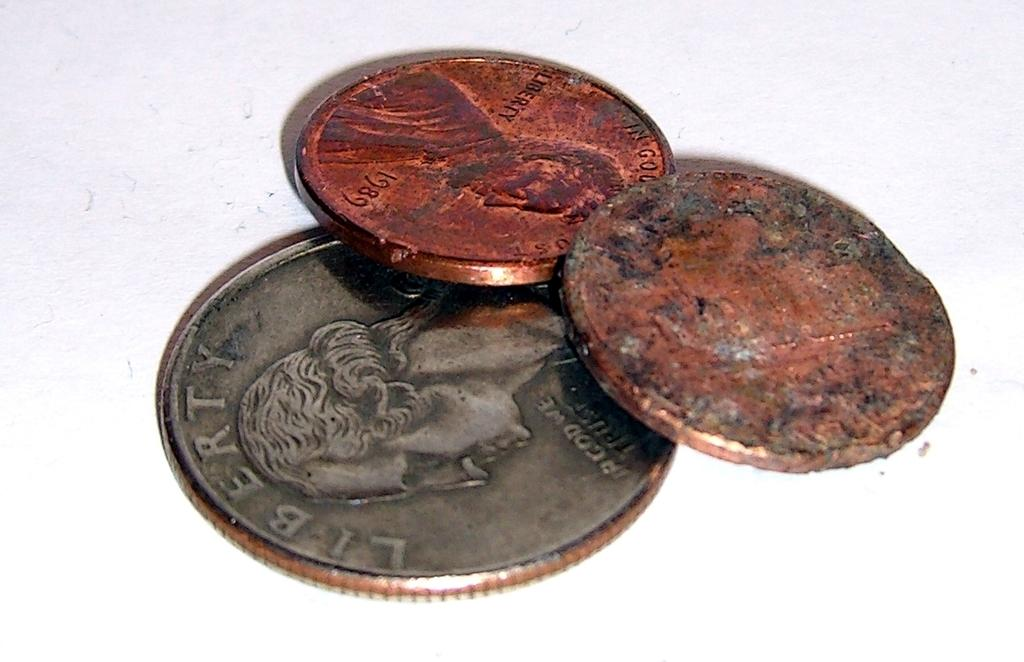<image>
Describe the image concisely. The silver coin on the bottom says Liberty on the top 